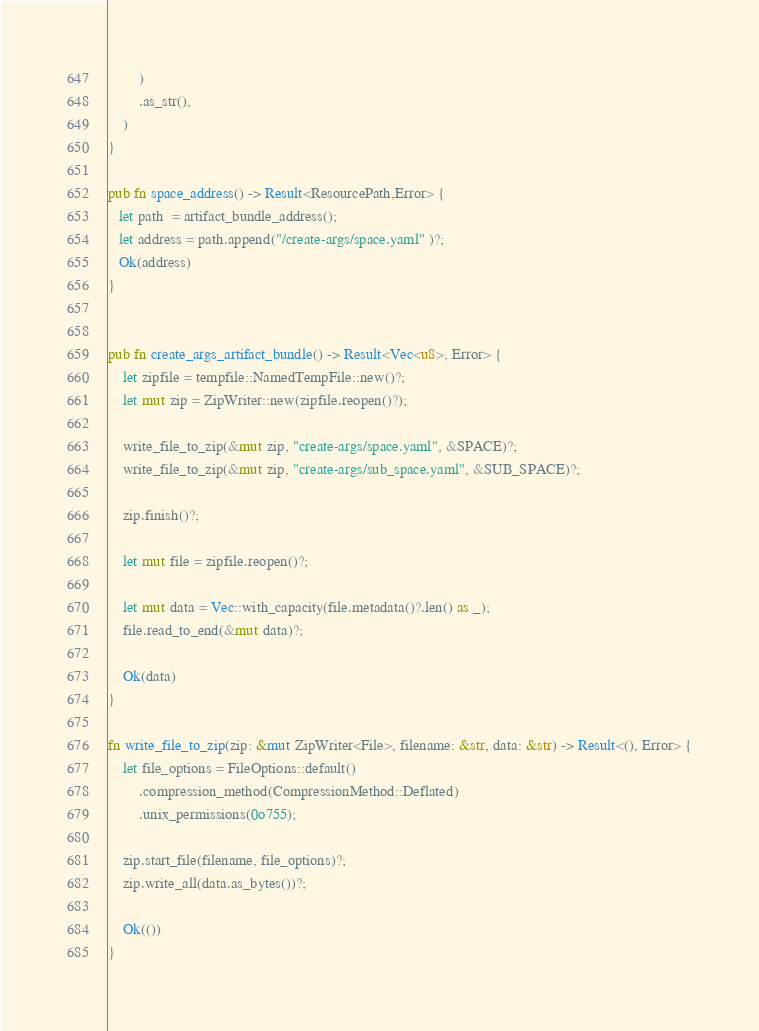Convert code to text. <code><loc_0><loc_0><loc_500><loc_500><_Rust_>        )
        .as_str(),
    )
}

pub fn space_address() -> Result<ResourcePath,Error> {
   let path  = artifact_bundle_address();
   let address = path.append("/create-args/space.yaml" )?;
   Ok(address)
}


pub fn create_args_artifact_bundle() -> Result<Vec<u8>, Error> {
    let zipfile = tempfile::NamedTempFile::new()?;
    let mut zip = ZipWriter::new(zipfile.reopen()?);

    write_file_to_zip(&mut zip, "create-args/space.yaml", &SPACE)?;
    write_file_to_zip(&mut zip, "create-args/sub_space.yaml", &SUB_SPACE)?;

    zip.finish()?;

    let mut file = zipfile.reopen()?;

    let mut data = Vec::with_capacity(file.metadata()?.len() as _);
    file.read_to_end(&mut data)?;

    Ok(data)
}

fn write_file_to_zip(zip: &mut ZipWriter<File>, filename: &str, data: &str) -> Result<(), Error> {
    let file_options = FileOptions::default()
        .compression_method(CompressionMethod::Deflated)
        .unix_permissions(0o755);

    zip.start_file(filename, file_options)?;
    zip.write_all(data.as_bytes())?;

    Ok(())
}
</code> 